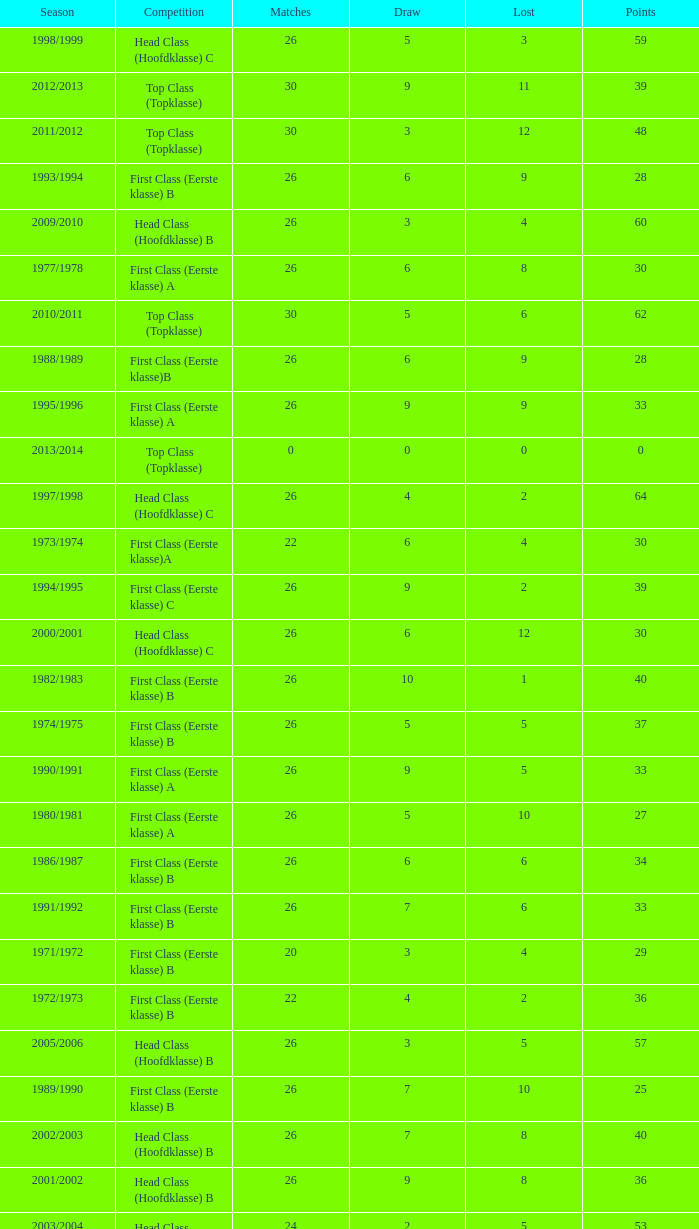Can you give me this table as a dict? {'header': ['Season', 'Competition', 'Matches', 'Draw', 'Lost', 'Points'], 'rows': [['1998/1999', 'Head Class (Hoofdklasse) C', '26', '5', '3', '59'], ['2012/2013', 'Top Class (Topklasse)', '30', '9', '11', '39'], ['2011/2012', 'Top Class (Topklasse)', '30', '3', '12', '48'], ['1993/1994', 'First Class (Eerste klasse) B', '26', '6', '9', '28'], ['2009/2010', 'Head Class (Hoofdklasse) B', '26', '3', '4', '60'], ['1977/1978', 'First Class (Eerste klasse) A', '26', '6', '8', '30'], ['2010/2011', 'Top Class (Topklasse)', '30', '5', '6', '62'], ['1988/1989', 'First Class (Eerste klasse)B', '26', '6', '9', '28'], ['1995/1996', 'First Class (Eerste klasse) A', '26', '9', '9', '33'], ['2013/2014', 'Top Class (Topklasse)', '0', '0', '0', '0'], ['1997/1998', 'Head Class (Hoofdklasse) C', '26', '4', '2', '64'], ['1973/1974', 'First Class (Eerste klasse)A', '22', '6', '4', '30'], ['1994/1995', 'First Class (Eerste klasse) C', '26', '9', '2', '39'], ['2000/2001', 'Head Class (Hoofdklasse) C', '26', '6', '12', '30'], ['1982/1983', 'First Class (Eerste klasse) B', '26', '10', '1', '40'], ['1974/1975', 'First Class (Eerste klasse) B', '26', '5', '5', '37'], ['1990/1991', 'First Class (Eerste klasse) A', '26', '9', '5', '33'], ['1980/1981', 'First Class (Eerste klasse) A', '26', '5', '10', '27'], ['1986/1987', 'First Class (Eerste klasse) B', '26', '6', '6', '34'], ['1991/1992', 'First Class (Eerste klasse) B', '26', '7', '6', '33'], ['1971/1972', 'First Class (Eerste klasse) B', '20', '3', '4', '29'], ['1972/1973', 'First Class (Eerste klasse) B', '22', '4', '2', '36'], ['2005/2006', 'Head Class (Hoofdklasse) B', '26', '3', '5', '57'], ['1989/1990', 'First Class (Eerste klasse) B', '26', '7', '10', '25'], ['2002/2003', 'Head Class (Hoofdklasse) B', '26', '7', '8', '40'], ['2001/2002', 'Head Class (Hoofdklasse) B', '26', '9', '8', '36'], ['2003/2004', 'Head Class (Hoofdklasse) B', '24', '2', '5', '53'], ['2004/2005', 'Head Class (Hoofdklasse) B', '26', '4', '6', '52'], ['1996/1997', 'Head Class (Hoofdklasse) B', '26', '7', '7', '43'], ['1976/1977', 'First Class (Eerste klasse) B', '26', '7', '3', '39'], ['2007/2008', 'Head Class (Hoofdklasse) B', '26', '6', '8', '42'], ['2006/2007', 'Head Class (Hoofdklasse) B', '26', '5', '3', '59'], ['1999/2000', 'Head Class (Hoofdklasse) C', '26', '3', '10', '42'], ['1975/1976', 'First Class (Eerste klasse)B', '26', '5', '3', '41'], ['1987/1988', 'First Class (Eerste klasse) A', '26', '5', '4', '39'], ['2008/2009', 'Head Class (Hoofdklasse) B', '26', '9', '2', '54'], ['1970/1971', 'First Class (Eerste klasse) A', '18', '6', '4', '24'], ['1981/1982', 'First Class (Eerste klasse) B', '26', '8', '3', '38'], ['1979/1980', 'First Class (Eerste klasse) B', '26', '6', '9', '28'], ['1978/1979', 'First Class (Eerste klasse) A', '26', '7', '6', '33'], ['1985/1986', 'First Class (Eerste klasse) B', '26', '7', '3', '39'], ['1992/1993', 'First Class (Eerste klasse) B', '26', '3', '11', '27'], ['1984/1985', 'First Class (Eerste klasse) B', '26', '6', '9', '28'], ['1983/1984', 'First Class (Eerste klasse) C', '26', '5', '3', '37']]} What competition has a score greater than 30, a draw less than 5, and a loss larger than 10? Top Class (Topklasse). 